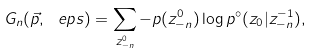<formula> <loc_0><loc_0><loc_500><loc_500>G _ { n } ( \vec { p } , \ e p s ) = \sum _ { z _ { - n } ^ { 0 } } - p ( z _ { - n } ^ { 0 } ) \log p ^ { \circ } ( z _ { 0 } | z _ { - n } ^ { - 1 } ) ,</formula> 